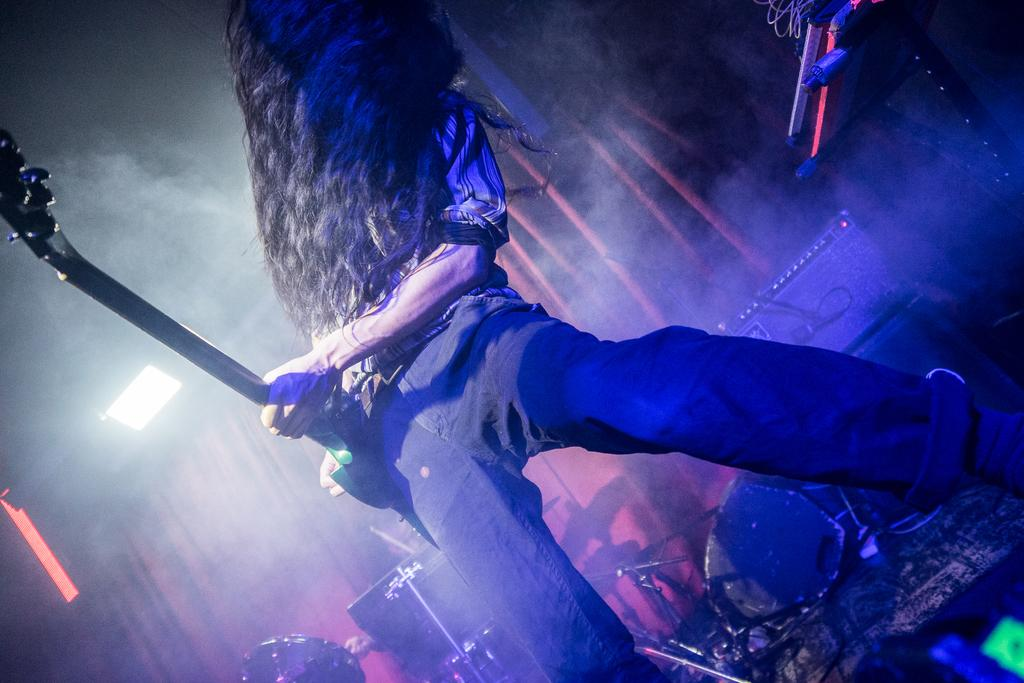Who is the main subject in the image? There is a man in the image. What is the man doing in the image? The man is standing and playing a guitar. Where is the man located in the image? The man is on a stage. What other musical instrument can be seen in the image? There are drums in the bottom of the image. What type of clouds can be seen in the image? There are no clouds present in the image; it features a man on a stage playing a guitar and drums. Can you tell me where the library is located in the image? There is no library present in the image. 